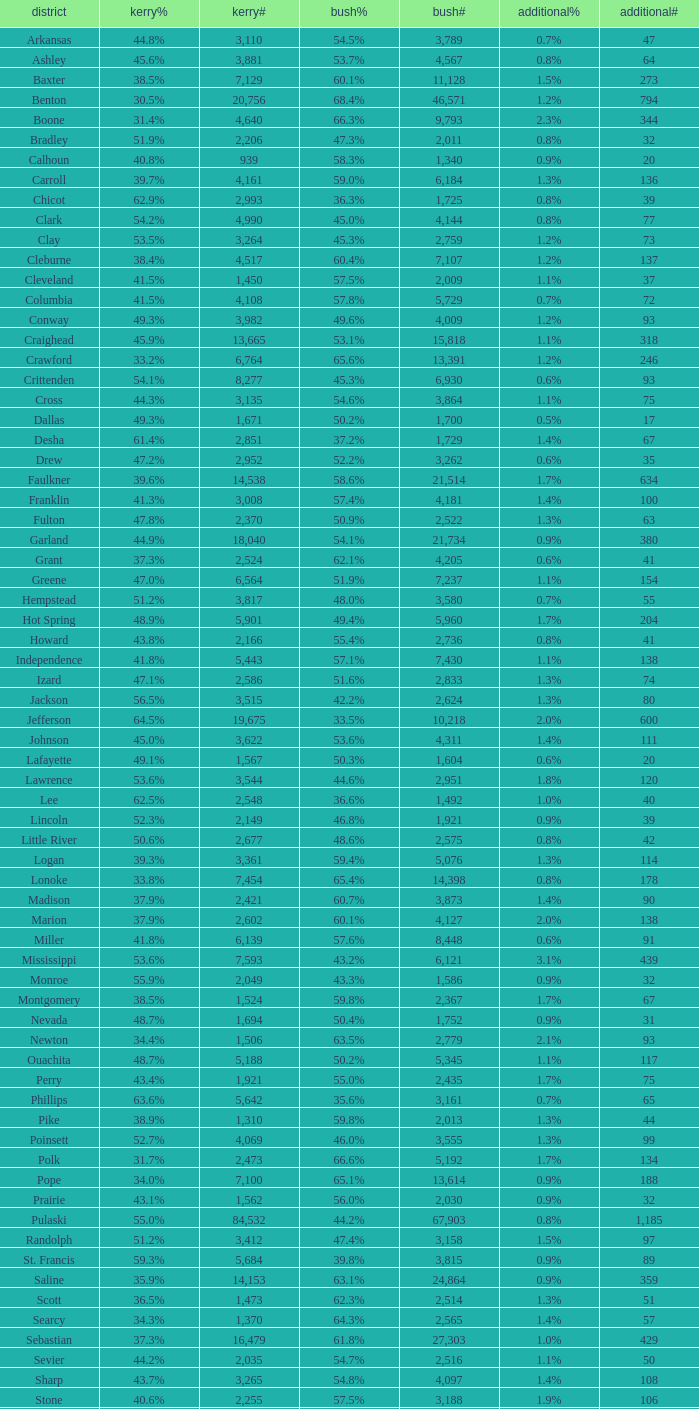What is the lowest Bush#, when Bush% is "65.4%"? 14398.0. 